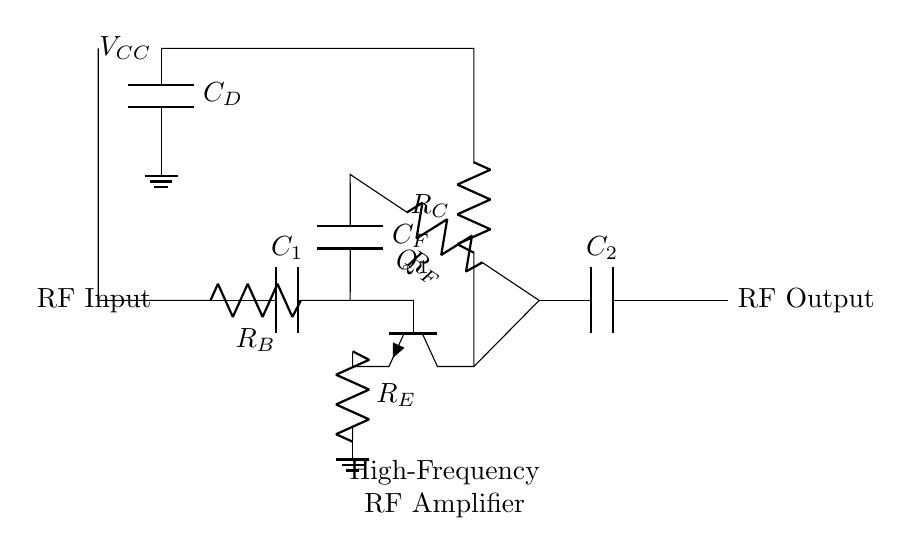What type of transistor is used in this amplifier? The circuit diagram indicates that an NPN transistor is used, as denoted by the npn label next to the transistor symbol.
Answer: NPN What is the purpose of capacitor C1 in this circuit? Capacitor C1 is connected at the input, which suggests it is used for coupling the RF signal into the amplifier while blocking any DC component.
Answer: Coupling What is the function of resistor R_B? Resistor R_B is used for biasing the base of the transistor to ensure proper operation and stability of the amplifier.
Answer: Biasing How many capacitors are present in the circuit? The circuit diagram shows four capacitors: C1, C2, CF, and CD. This includes coupling, feedback, and decoupling capacitors.
Answer: Four What role does resistor R_E play in this amplifier circuit? Resistor R_E is an emitter resistor, which helps to stabilize the transistor's operating point and improve linearity by providing negative feedback.
Answer: Stabilization What can be inferred about the feedback mechanism in the circuit? The feedback is provided by R_F and C_F, which connect the output back to the input, allowing for better control of gain and frequency response in the amplifier.
Answer: Feedback control What does the presence of coupling capacitors indicate about the expected signals in the circuit? The coupling capacitors (C1 and C2) indicate that the circuit is designed to handle alternating signals (like RF), rather than direct current signals.
Answer: Alternating signals 